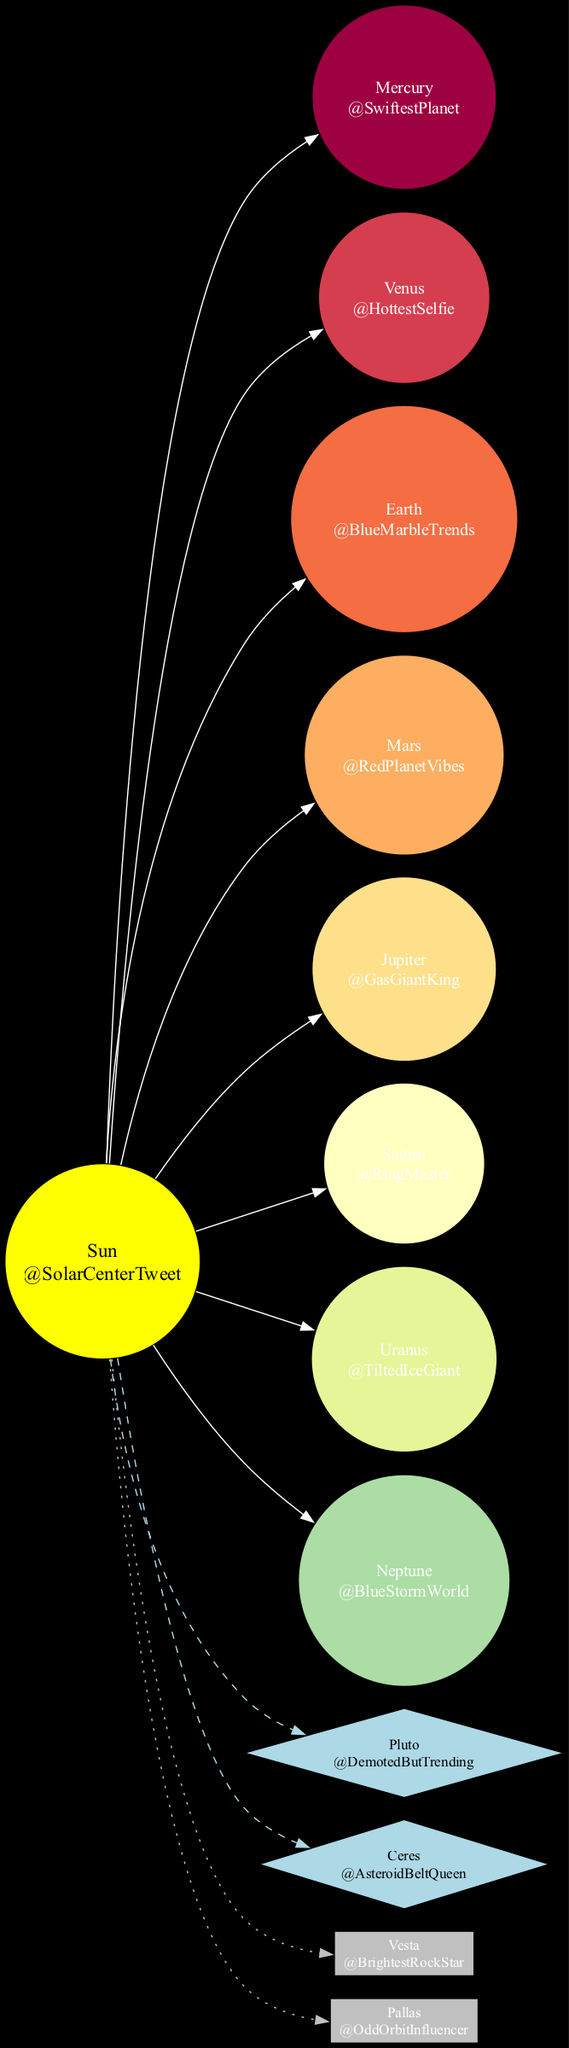What is the central object of the Solar System? The central object is labeled as "Sun" in the diagram. This is evident from the way it’s positioned at the center of the diagram, with edges connecting all the planets, dwarf planets, and asteroids to it.
Answer: Sun How many planets are there in the Solar System according to the diagram? The diagram lists a total of eight planets surrounding the Sun, each connected by an edge. Counting them gives us Mercury, Venus, Earth, Mars, Jupiter, Saturn, Uranus, and Neptune, confirming that there are eight planets.
Answer: 8 What is the Twitter handle of Mars? In the diagram, Mars has its handle shown as "@RedPlanetVibes." The handle is displayed right below the planet's name inside its node.
Answer: @RedPlanetVibes Which celestial object has a dashed line connection to the Sun? The dashed line connection indicates an association with a dwarf planet. In the diagram, both Pluto and Ceres are linked to the Sun by dashed lines, denoting that both have this relationship.
Answer: Pluto and Ceres What is unique about the shape of dwarf planets compared to planets in the diagram? Dwarf planets are represented in a diamond shape, while full planets are shown as circles. This distinction emphasizes their different classification within the structure of the Solar System, visually separating them from standard planets.
Answer: Diamond shape Which celestial body is the farthest from the Sun according to the diagram? To determine this, you would look at the positioning of the objects in relation to the Sun. Neptune, being the last planet listed, is the one that is typically the farthest from the Sun in the Solar System.
Answer: Neptune How many major asteroids are represented in the diagram? The diagram includes two major asteroids, Vesta and Pallas, both of which are shown as boxes connected to the Sun. Thus, counting them gives us two.
Answer: 2 Which planet is referred to as the "Gas Giant King"? The label "Gas Giant King" is associated with Jupiter in the diagram, clearly indicated in the node that represents Jupiter. This nickname can be seen under the planet's name, providing a direct answer.
Answer: Jupiter What color represents the major asteroids on the diagram? Major asteroids are represented in gray. This is evident from the filled color of the box shapes that represent these asteroids in connection with the Sun.
Answer: Gray 